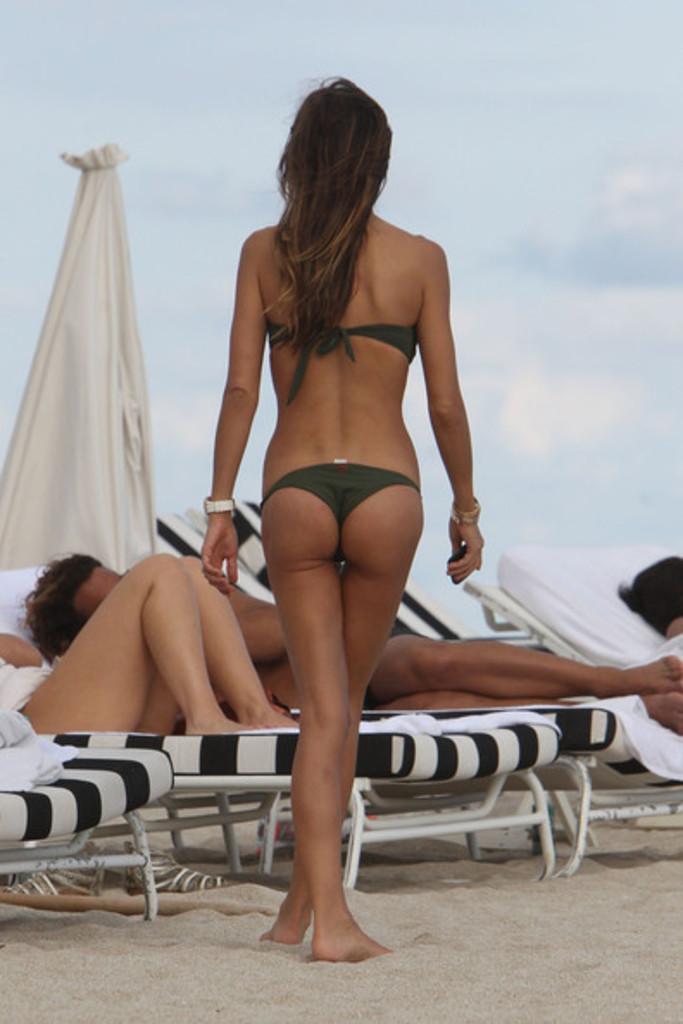How would you summarize this image in a sentence or two? This picture is clicked outside the city. In the center there is a woman wearing a bikini and walking on the ground and we can see the group of people lying on the beach chairs and we can see the sandals placed on the ground. In the background there is a white color object seems to be a tent and we can see the sky. 